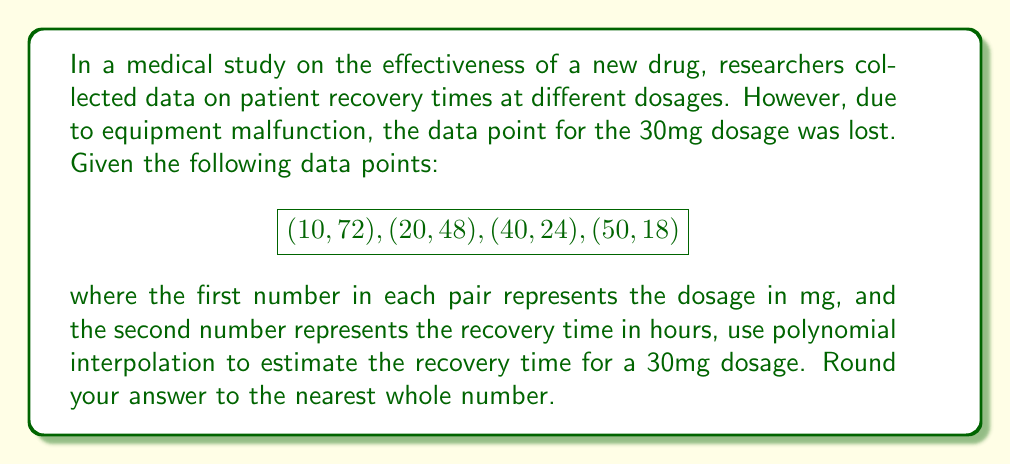Teach me how to tackle this problem. To solve this problem, we'll use Lagrange polynomial interpolation:

1) The Lagrange interpolation polynomial is given by:
   $$L(x) = \sum_{i=1}^n y_i \prod_{j \neq i} \frac{x - x_j}{x_i - x_j}$$

2) For our data points:
   $$(x_1, y_1) = (10, 72)$$
   $$(x_2, y_2) = (20, 48)$$
   $$(x_3, y_3) = (40, 24)$$
   $$(x_4, y_4) = (50, 18)$$

3) We need to calculate $L(30)$:
   $$L(30) = 72 \cdot \frac{(30-20)(30-40)(30-50)}{(10-20)(10-40)(10-50)} + 
             48 \cdot \frac{(30-10)(30-40)(30-50)}{(20-10)(20-40)(20-50)} +$$
   $$        24 \cdot \frac{(30-10)(30-20)(30-50)}{(40-10)(40-20)(40-50)} + 
             18 \cdot \frac{(30-10)(30-20)(30-40)}{(50-10)(50-20)(50-40)}$$

4) Calculating each term:
   $$72 \cdot \frac{10 \cdot (-10) \cdot (-20)}{(-10) \cdot (-30) \cdot (-40)} = -8.64$$
   $$48 \cdot \frac{20 \cdot (-10) \cdot (-20)}{10 \cdot (-20) \cdot (-30)} = 32$$
   $$24 \cdot \frac{20 \cdot 10 \cdot (-20)}{30 \cdot 20 \cdot (-10)} = -32$$
   $$18 \cdot \frac{20 \cdot 10 \cdot (-10)}{40 \cdot 30 \cdot 10} = -12$$

5) Sum the terms:
   $$L(30) = -8.64 + 32 - 32 - 12 = -20.64$$

6) Rounding to the nearest whole number:
   $$L(30) \approx -21$$

Since recovery time cannot be negative, we interpret this as 21 hours.
Answer: 21 hours 